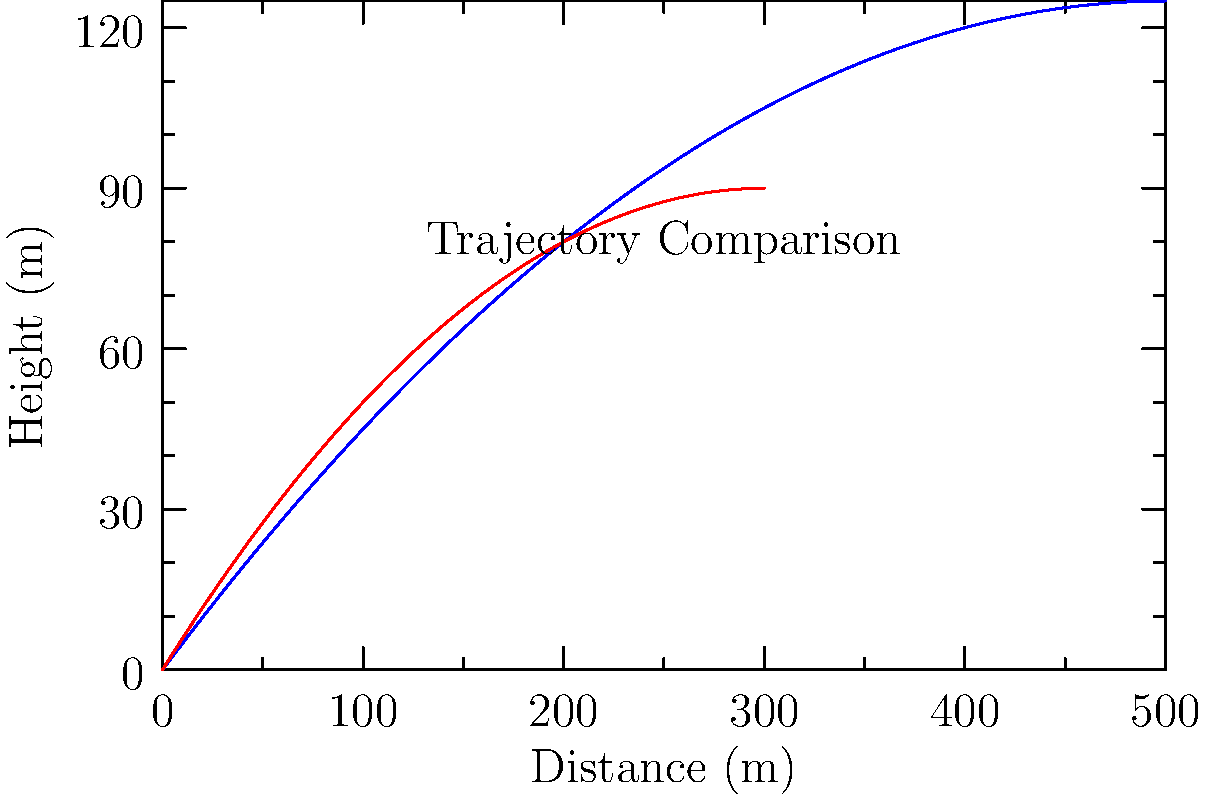Given the trajectory graphs for a rifle and a pistol, estimate the effective range of the pistol if the rifle's effective range is known to be 400 meters. Assume the effective range is determined by the point where the projectile's height reaches zero after its peak. To solve this problem, we need to analyze the trajectory graphs and compare the two weapons:

1. Observe that both graphs are parabolic, representing the typical trajectory of a projectile.

2. The blue curve represents the rifle's trajectory, while the red curve represents the pistol's trajectory.

3. We're told that the rifle's effective range is 400 meters. This corresponds to the x-intercept of the blue curve.

4. To estimate the pistol's effective range, we need to find the x-intercept of the red curve.

5. Comparing the two curves:
   a) The pistol's curve (red) peaks earlier and lower than the rifle's curve (blue).
   b) The pistol's curve appears to intersect the x-axis at about 3/4 the distance of the rifle's curve.

6. Since the rifle's range is 400 meters, we can estimate the pistol's range as:
   $$400 \times \frac{3}{4} = 300 \text{ meters}$$

Therefore, the estimated effective range of the pistol is approximately 300 meters.
Answer: 300 meters 